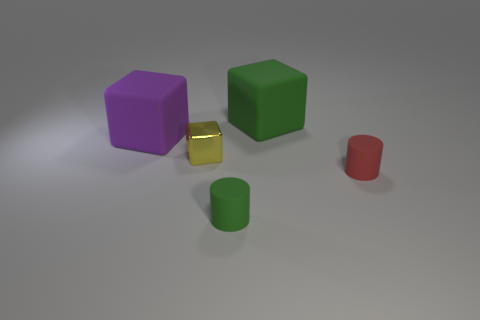Subtract all large rubber cubes. How many cubes are left? 1 Add 3 matte objects. How many objects exist? 8 Subtract all red cylinders. How many cylinders are left? 1 Subtract 0 purple spheres. How many objects are left? 5 Subtract all cubes. How many objects are left? 2 Subtract all cyan blocks. Subtract all blue cylinders. How many blocks are left? 3 Subtract all yellow cubes. How many red cylinders are left? 1 Subtract all big shiny cubes. Subtract all purple cubes. How many objects are left? 4 Add 3 tiny cylinders. How many tiny cylinders are left? 5 Add 1 red objects. How many red objects exist? 2 